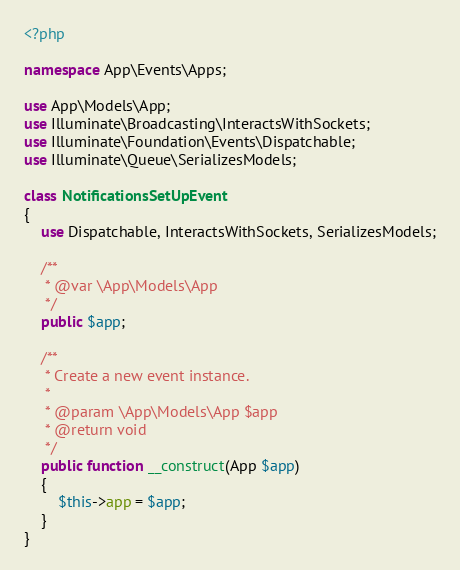<code> <loc_0><loc_0><loc_500><loc_500><_PHP_><?php

namespace App\Events\Apps;

use App\Models\App;
use Illuminate\Broadcasting\InteractsWithSockets;
use Illuminate\Foundation\Events\Dispatchable;
use Illuminate\Queue\SerializesModels;

class NotificationsSetUpEvent
{
    use Dispatchable, InteractsWithSockets, SerializesModels;

    /**
     * @var \App\Models\App
     */
    public $app;

    /**
     * Create a new event instance.
     *
     * @param \App\Models\App $app
     * @return void
     */
    public function __construct(App $app)
    {
        $this->app = $app;
    }
}
</code> 